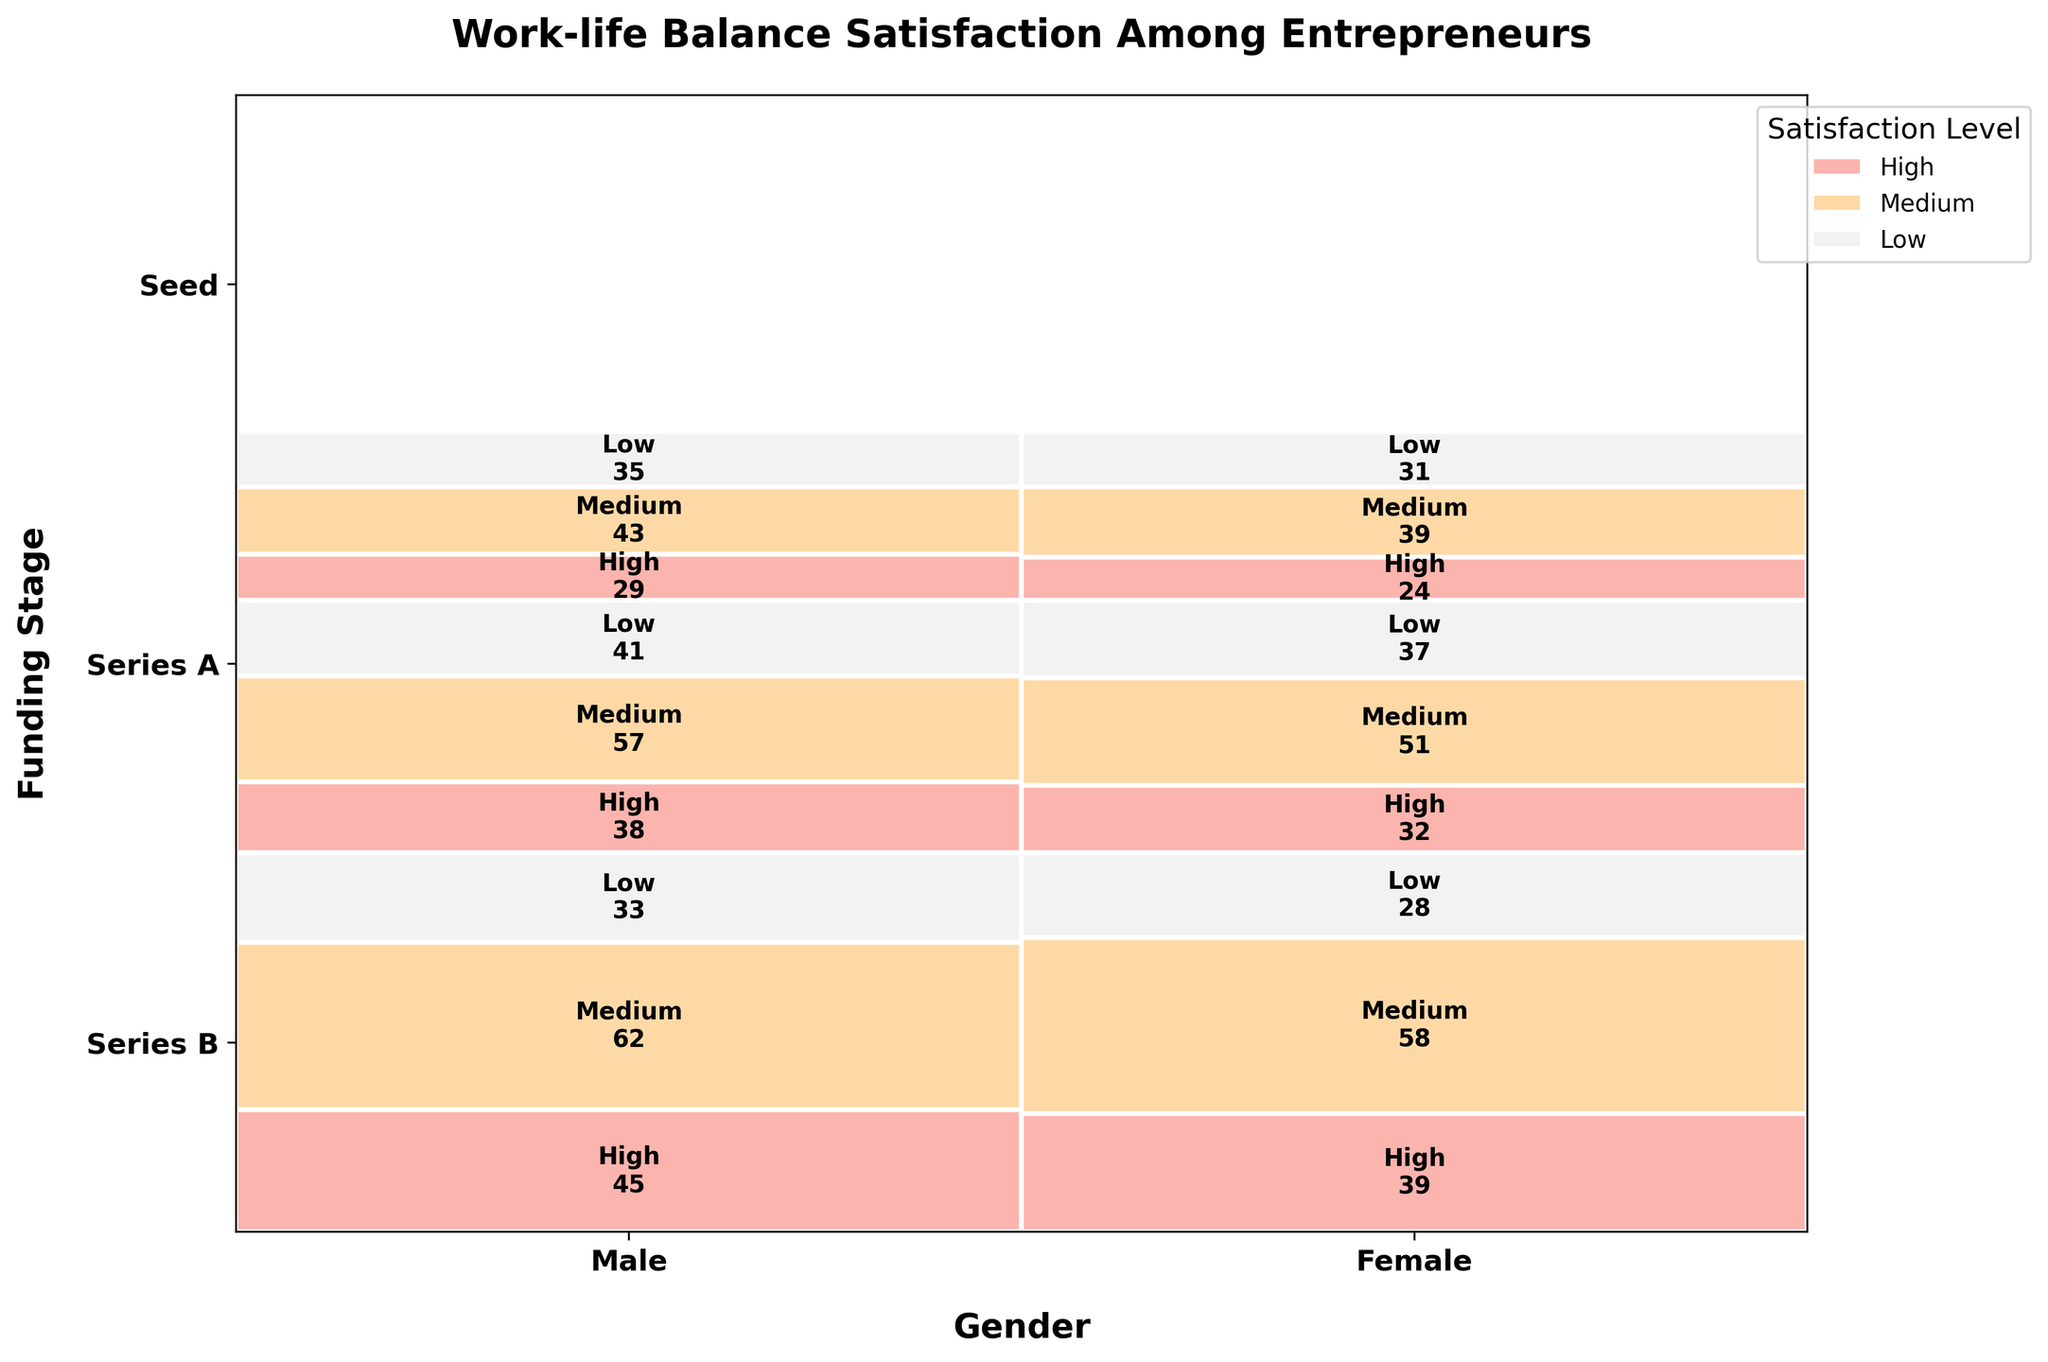What is the title of the figure? Look at the top of the figure to find the title.
Answer: Work-life Balance Satisfaction Among Entrepreneurs How many satisfaction levels are represented in the plot and what are they? Identify all different categories of satisfaction mentioned in the legend or within the plot. There are three satisfaction levels indicated by different colors.
Answer: High, Medium, Low Which gender has a higher count of high satisfaction levels at the Seed funding stage? Compare the segments for high satisfaction at the Seed funding stage for both Male and Female sides of the plot. The section with the larger area represents the higher count.
Answer: Male What is the total number of entrepreneurs with medium satisfaction at the Series A funding stage? Sum the count of both genders from the Series A funding stage sections within the Medium satisfaction levels. For Male and Female, the counts are 57 and 51 respectively.
Answer: 108 What gender and funding stage combination has the lowest count of high satisfaction? Look for the smallest segment in the plot corresponding to high satisfaction within gender and funding stage combinations.
Answer: Female, Series B In which funding stage do males have the highest medium satisfaction count? Compare the medium satisfaction sections for males across Seed, Series A, and Series B funding stages to find the one with the greatest count.
Answer: Seed How does the count of low satisfaction females in Series B compare with that of males in Series B? Compare the section for low satisfaction in the Series B stage for both Male and Female. The Male count is higher than Female. (35 vs 31)
Answer: Higher for males What can be observed about the trend of high satisfaction counts for males across different funding stages? Review the segments for high satisfaction across Seed, Series A, and Series B for males and describe the pattern. High satisfaction count decreases from Seed (45) to Series A (38) to Series B (29).
Answer: Decreasing trend Do females or males have a higher count of entrepreneurs with low satisfaction at the Seed stage? Compare the sections representing low satisfaction at the Seed stage for both genders to determine which is higher.
Answer: Males At which funding stage do females have almost equal counts of low and high satisfaction levels? Examine the female sections for low and high satisfaction across all funding stages. For Series A, counts for low (37) and high (32) satisfaction are close.
Answer: Series A 